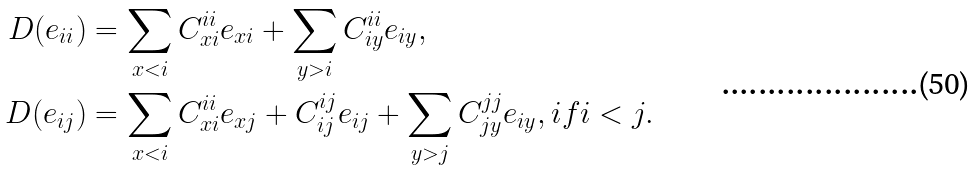<formula> <loc_0><loc_0><loc_500><loc_500>D ( e _ { i i } ) & = \sum _ { x < i } C _ { x i } ^ { i i } e _ { x i } + \sum _ { y > i } C _ { i y } ^ { i i } e _ { i y } , \\ D ( e _ { i j } ) & = \sum _ { x < i } C _ { x i } ^ { i i } e _ { x j } + C _ { i j } ^ { i j } e _ { i j } + \sum _ { y > j } C _ { j y } ^ { j j } e _ { i y } , i f i < j .</formula> 